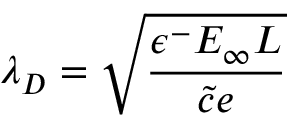Convert formula to latex. <formula><loc_0><loc_0><loc_500><loc_500>\lambda _ { D } = \sqrt { \frac { \epsilon ^ { - } E _ { \infty } L } { \tilde { c } e } }</formula> 